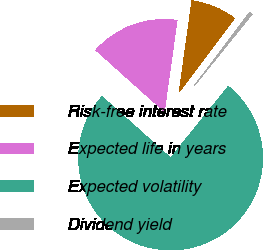Convert chart. <chart><loc_0><loc_0><loc_500><loc_500><pie_chart><fcel>Risk-free interest rate<fcel>Expected life in years<fcel>Expected volatility<fcel>Dividend yield<nl><fcel>8.06%<fcel>15.58%<fcel>75.82%<fcel>0.54%<nl></chart> 